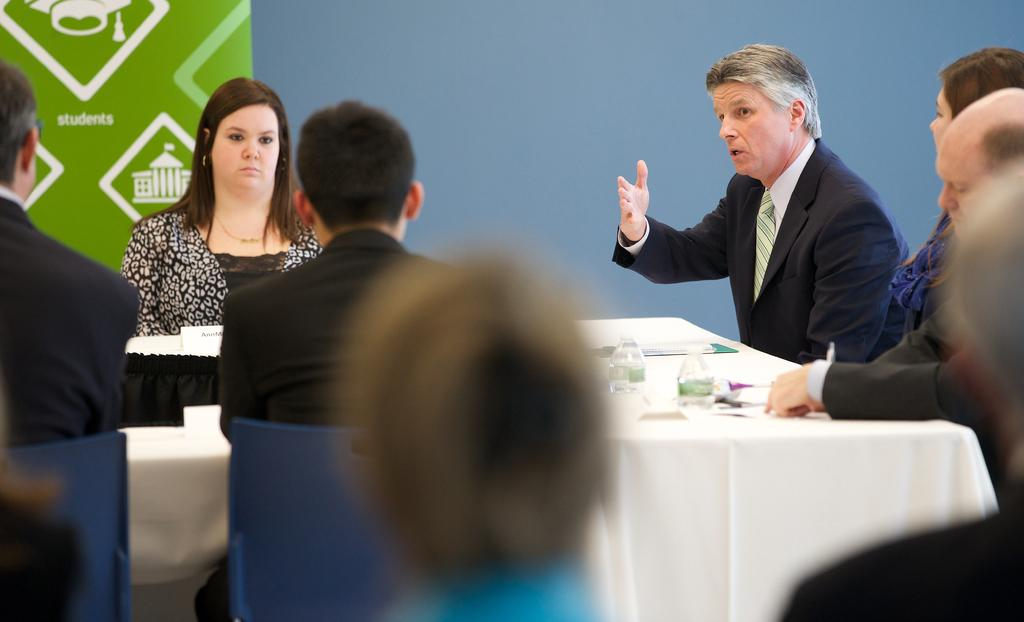What are the people in the image doing? There is a group of people sitting in the image. Can you describe the actions of one of the individuals? A man is talking while sitting. What objects can be seen on the table in the image? There are two bottles on a table. What can be seen in the background of the image? There is a wall visible in the background of the image. Where is the cactus located in the image? There is no cactus present in the image. What type of battle is taking place in the image? There is no battle present in the image; it features a group of people sitting and talking. 